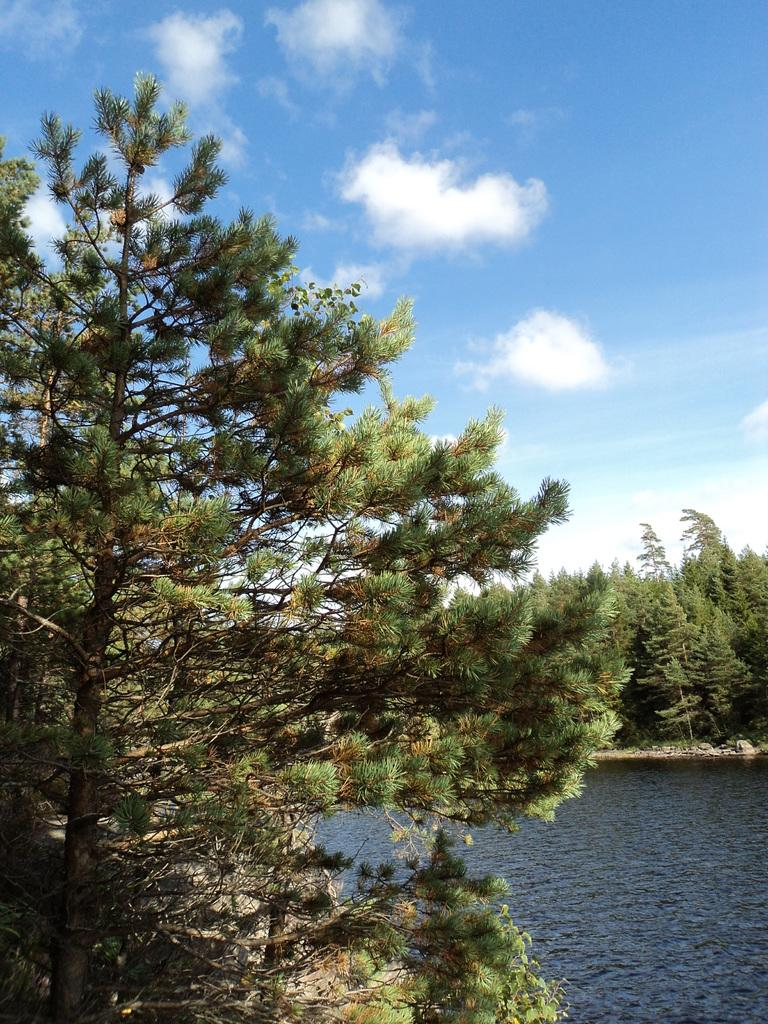What type of vegetation can be seen in the image? There are trees in the image. What is located at the bottom of the image? There is water at the bottom of the image. What can be seen in the sky at the top of the image? There are clouds in the sky at the top of the image. How many tomatoes are hanging from the trees in the image? There are no tomatoes present in the image; it features trees and water. Is there a person wearing a hat in the image? There is no person or hat present in the image. 